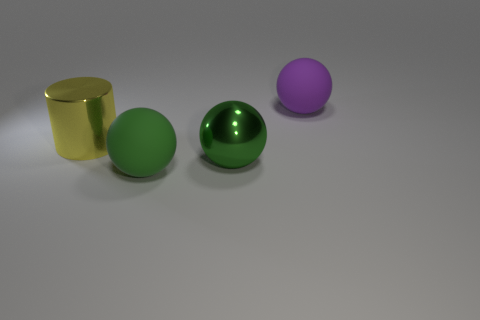Add 1 tiny gray metal blocks. How many objects exist? 5 Subtract all balls. How many objects are left? 1 Add 2 green metallic things. How many green metallic things exist? 3 Subtract 0 gray blocks. How many objects are left? 4 Subtract all big shiny objects. Subtract all large green metallic balls. How many objects are left? 1 Add 1 big purple rubber objects. How many big purple rubber objects are left? 2 